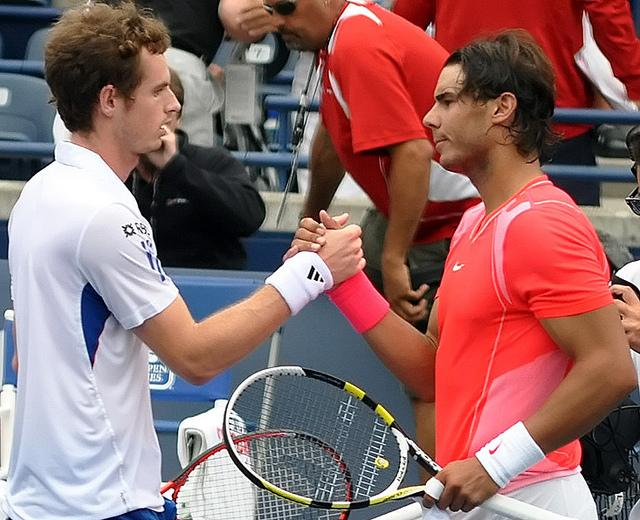What did the two men shaking hands just do? Please explain your reasoning. played tennis. The two men just had a match. 